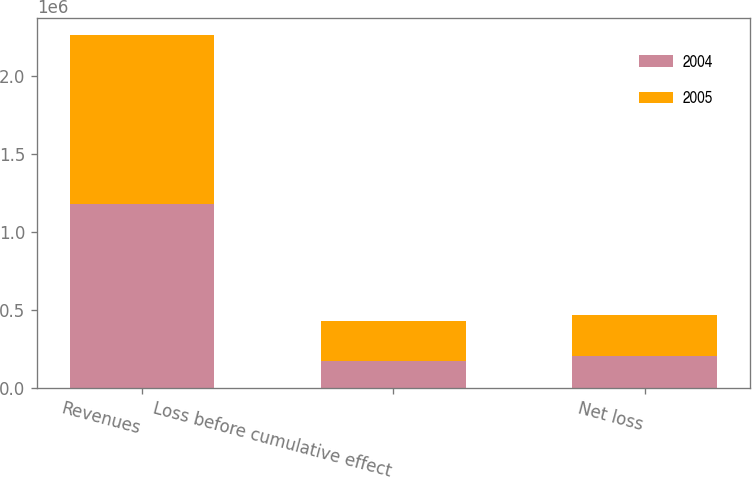Convert chart. <chart><loc_0><loc_0><loc_500><loc_500><stacked_bar_chart><ecel><fcel>Revenues<fcel>Loss before cumulative effect<fcel>Net loss<nl><fcel>2004<fcel>1.17828e+06<fcel>168068<fcel>203594<nl><fcel>2005<fcel>1.08039e+06<fcel>260732<fcel>260732<nl></chart> 